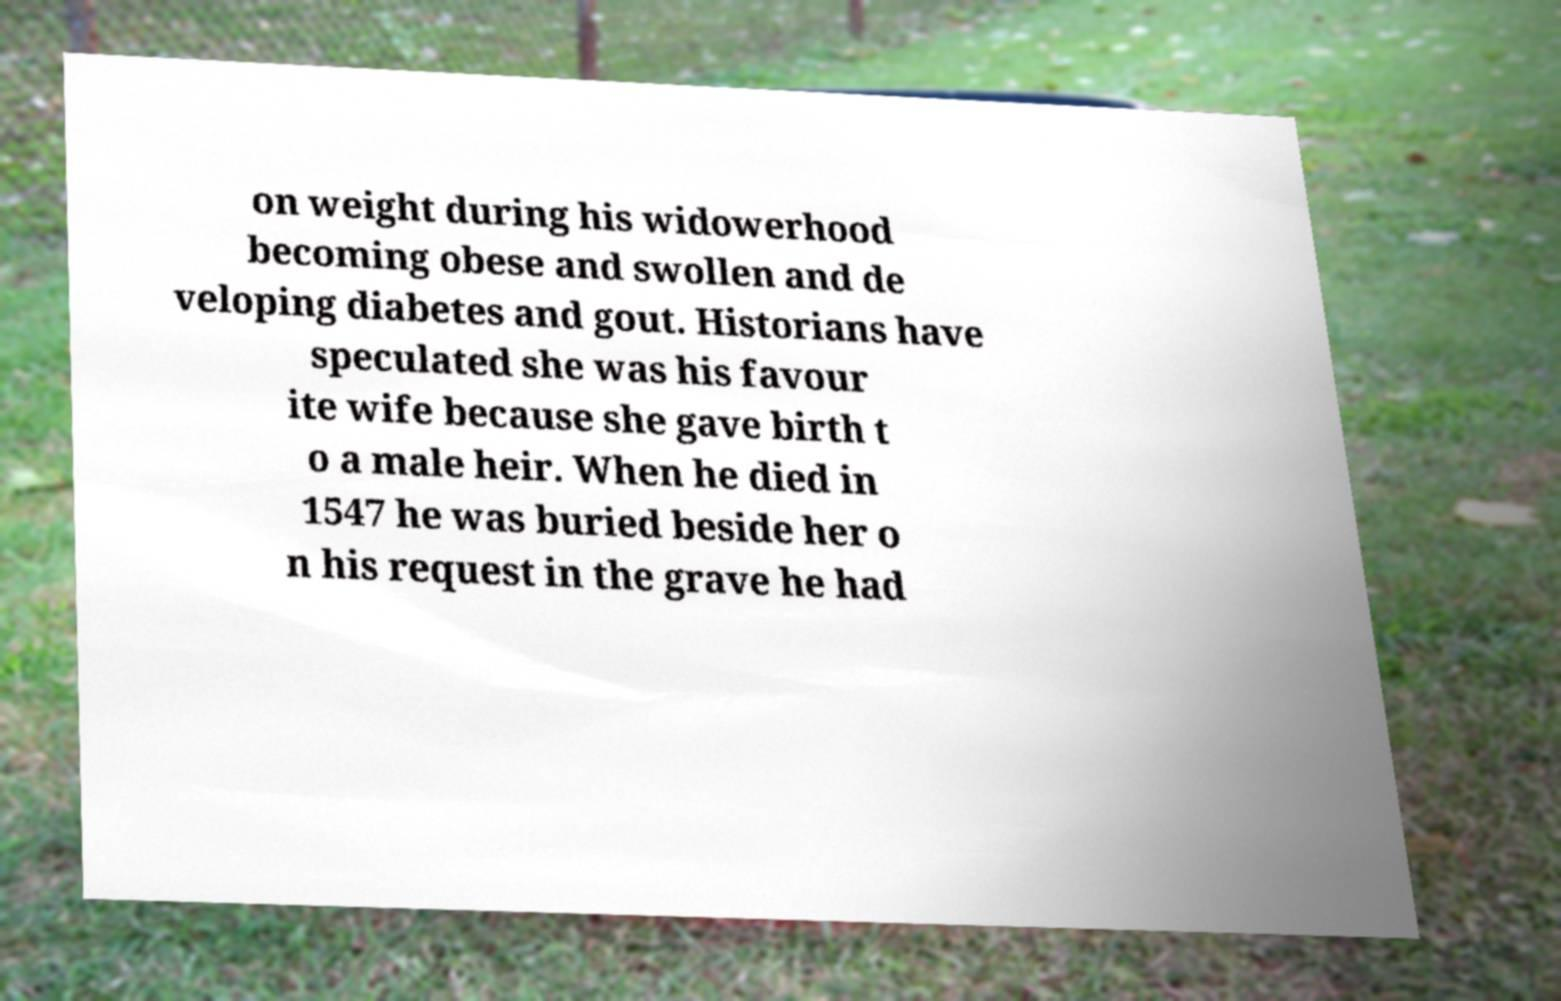Please read and relay the text visible in this image. What does it say? on weight during his widowerhood becoming obese and swollen and de veloping diabetes and gout. Historians have speculated she was his favour ite wife because she gave birth t o a male heir. When he died in 1547 he was buried beside her o n his request in the grave he had 